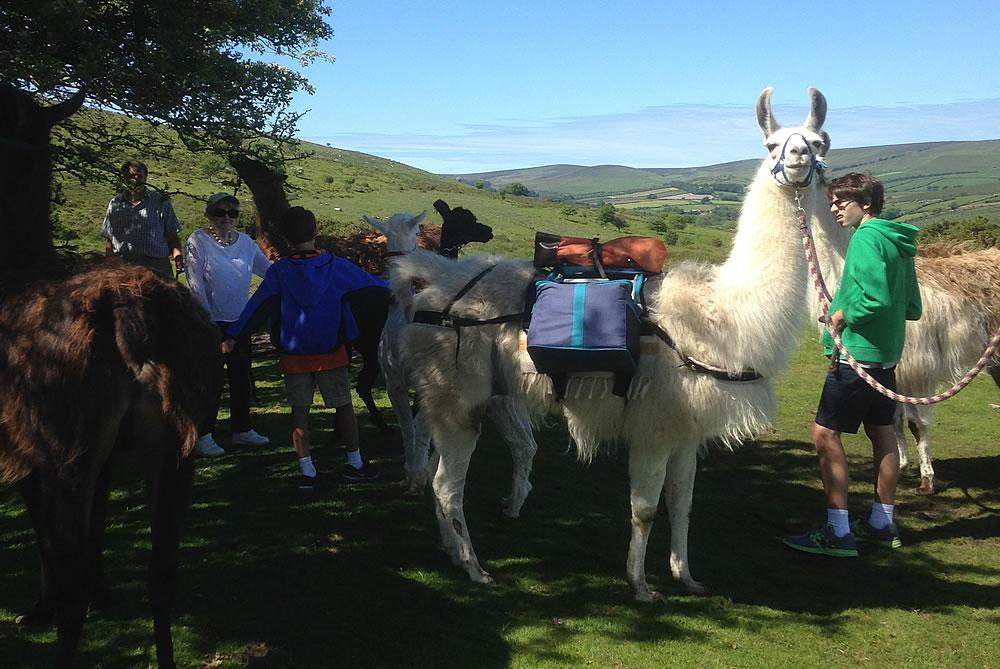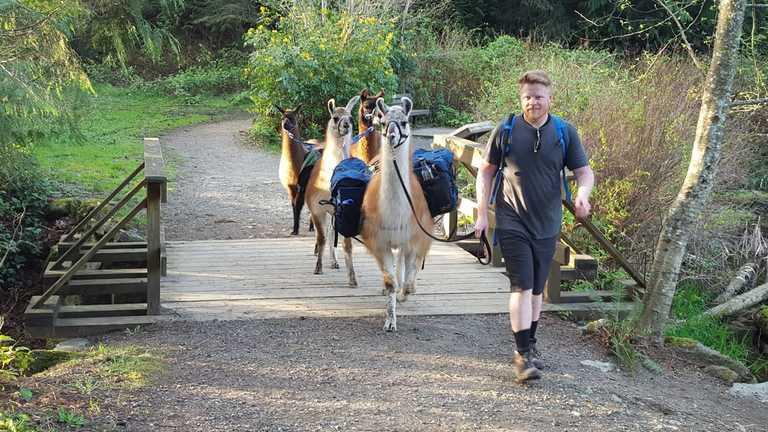The first image is the image on the left, the second image is the image on the right. Evaluate the accuracy of this statement regarding the images: "There are humans riding the llamas.". Is it true? Answer yes or no. No. The first image is the image on the left, the second image is the image on the right. For the images shown, is this caption "At least one person can be seen riding a llama." true? Answer yes or no. No. 